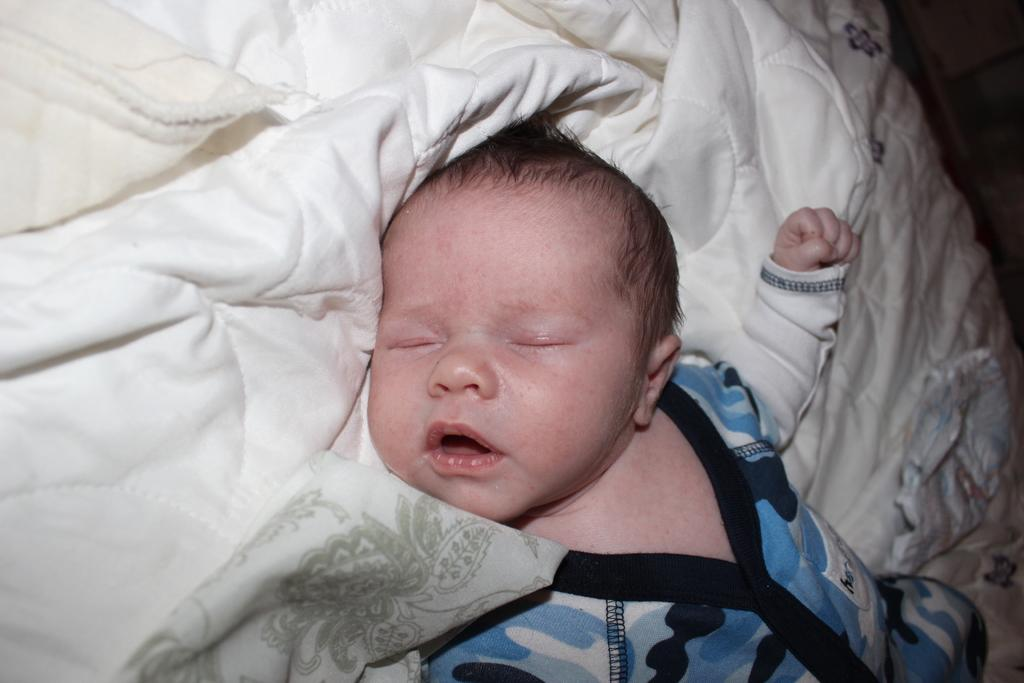What is the main subject of the image? The main subject of the image is a baby boy. What is the baby boy doing in the image? The baby boy is sleeping on the bed. What type of clothing is the baby boy wearing? The baby boy is wearing a t-shirt and trousers. What can be seen at the top of the image? There is a bed sheet visible at the top of the image. What type of coat is hanging on the shelf in the image? There is no coat or shelf present in the image; it features a baby boy sleeping on a bed with a visible bed sheet. 